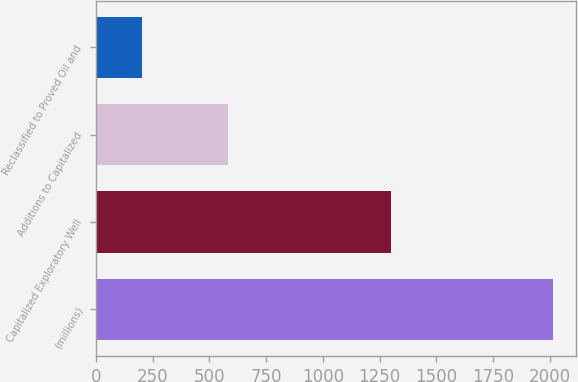Convert chart to OTSL. <chart><loc_0><loc_0><loc_500><loc_500><bar_chart><fcel>(millions)<fcel>Capitalized Exploratory Well<fcel>Additions to Capitalized<fcel>Reclassified to Proved Oil and<nl><fcel>2013<fcel>1301<fcel>581<fcel>204<nl></chart> 